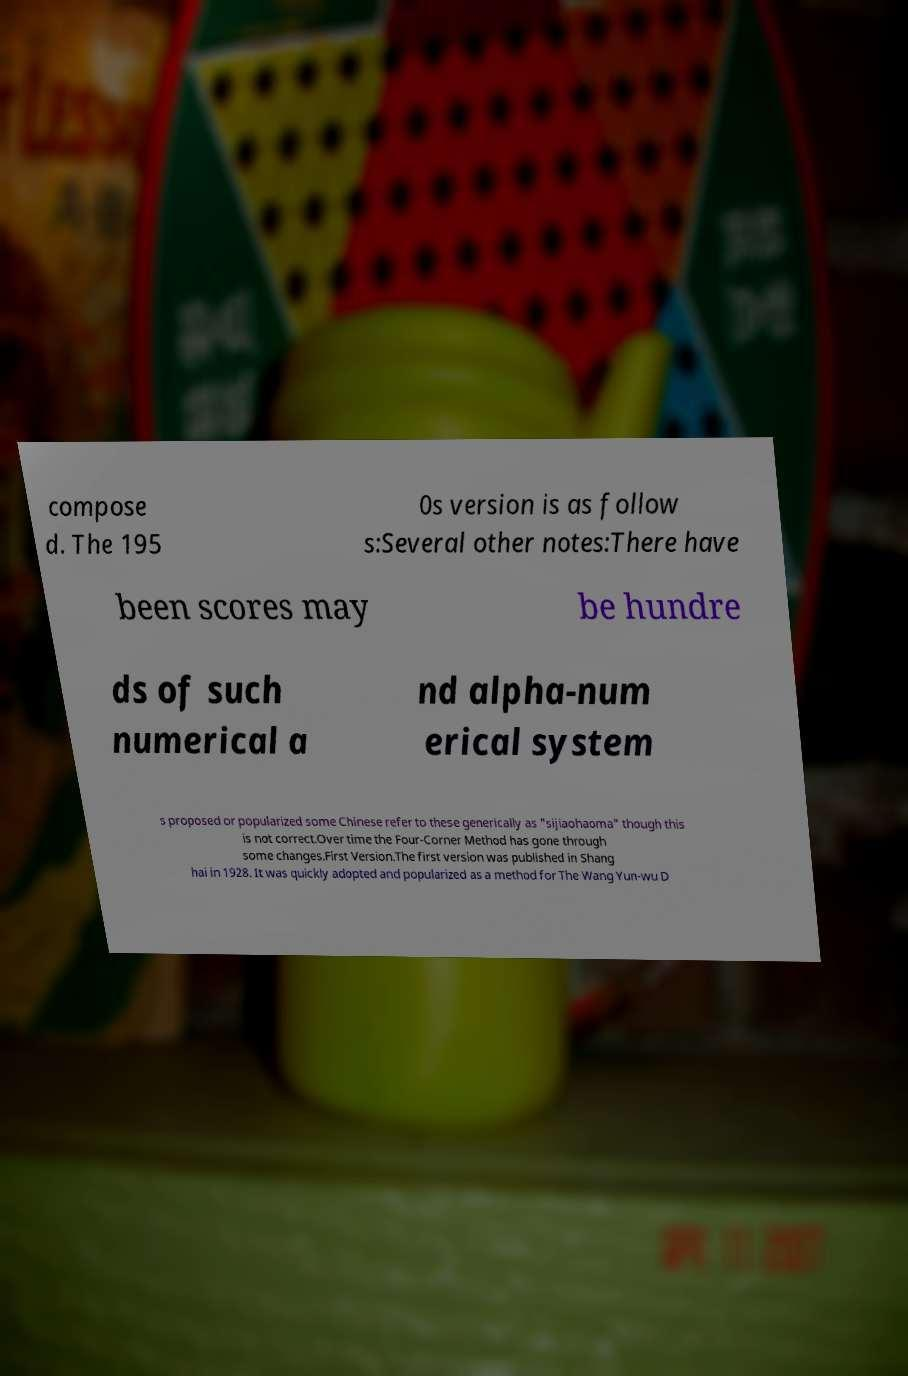Could you extract and type out the text from this image? compose d. The 195 0s version is as follow s:Several other notes:There have been scores may be hundre ds of such numerical a nd alpha-num erical system s proposed or popularized some Chinese refer to these generically as "sijiaohaoma" though this is not correct.Over time the Four-Corner Method has gone through some changes.First Version.The first version was published in Shang hai in 1928. It was quickly adopted and popularized as a method for The Wang Yun-wu D 